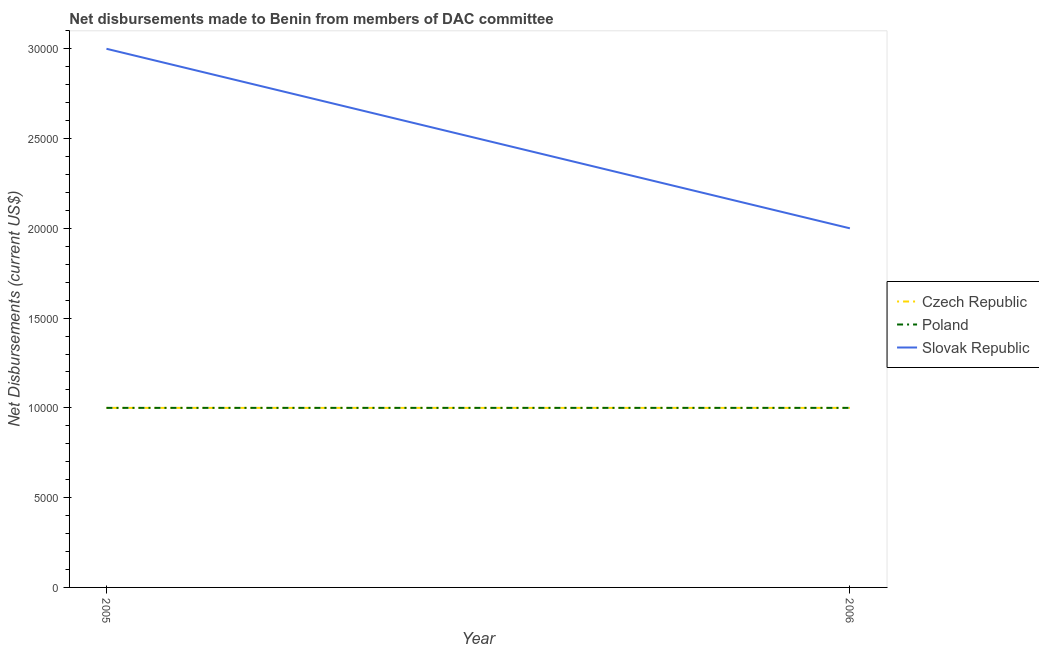How many different coloured lines are there?
Give a very brief answer. 3. What is the net disbursements made by slovak republic in 2006?
Give a very brief answer. 2.00e+04. Across all years, what is the maximum net disbursements made by czech republic?
Provide a short and direct response. 10000. Across all years, what is the minimum net disbursements made by slovak republic?
Offer a terse response. 2.00e+04. In which year was the net disbursements made by slovak republic maximum?
Provide a short and direct response. 2005. In which year was the net disbursements made by czech republic minimum?
Make the answer very short. 2005. What is the total net disbursements made by poland in the graph?
Ensure brevity in your answer.  2.00e+04. What is the difference between the net disbursements made by slovak republic in 2006 and the net disbursements made by poland in 2005?
Offer a terse response. 10000. In the year 2006, what is the difference between the net disbursements made by slovak republic and net disbursements made by poland?
Your response must be concise. 10000. In how many years, is the net disbursements made by poland greater than 5000 US$?
Keep it short and to the point. 2. What is the ratio of the net disbursements made by slovak republic in 2005 to that in 2006?
Offer a very short reply. 1.5. In how many years, is the net disbursements made by poland greater than the average net disbursements made by poland taken over all years?
Offer a very short reply. 0. How many lines are there?
Provide a succinct answer. 3. How many years are there in the graph?
Your answer should be compact. 2. What is the difference between two consecutive major ticks on the Y-axis?
Provide a short and direct response. 5000. Does the graph contain grids?
Give a very brief answer. No. How many legend labels are there?
Your response must be concise. 3. What is the title of the graph?
Make the answer very short. Net disbursements made to Benin from members of DAC committee. Does "Taxes on goods and services" appear as one of the legend labels in the graph?
Your answer should be compact. No. What is the label or title of the X-axis?
Ensure brevity in your answer.  Year. What is the label or title of the Y-axis?
Offer a very short reply. Net Disbursements (current US$). What is the Net Disbursements (current US$) in Czech Republic in 2005?
Provide a short and direct response. 10000. What is the Net Disbursements (current US$) in Poland in 2005?
Offer a terse response. 10000. What is the Net Disbursements (current US$) in Slovak Republic in 2005?
Give a very brief answer. 3.00e+04. What is the Net Disbursements (current US$) of Czech Republic in 2006?
Provide a succinct answer. 10000. What is the Net Disbursements (current US$) in Poland in 2006?
Provide a short and direct response. 10000. What is the Net Disbursements (current US$) in Slovak Republic in 2006?
Keep it short and to the point. 2.00e+04. Across all years, what is the maximum Net Disbursements (current US$) of Czech Republic?
Offer a terse response. 10000. Across all years, what is the maximum Net Disbursements (current US$) in Poland?
Your response must be concise. 10000. Across all years, what is the maximum Net Disbursements (current US$) of Slovak Republic?
Your response must be concise. 3.00e+04. Across all years, what is the minimum Net Disbursements (current US$) in Czech Republic?
Provide a succinct answer. 10000. Across all years, what is the minimum Net Disbursements (current US$) of Poland?
Offer a very short reply. 10000. What is the total Net Disbursements (current US$) in Czech Republic in the graph?
Your response must be concise. 2.00e+04. What is the difference between the Net Disbursements (current US$) of Czech Republic in 2005 and the Net Disbursements (current US$) of Slovak Republic in 2006?
Your response must be concise. -10000. What is the difference between the Net Disbursements (current US$) in Poland in 2005 and the Net Disbursements (current US$) in Slovak Republic in 2006?
Your answer should be very brief. -10000. What is the average Net Disbursements (current US$) of Poland per year?
Provide a succinct answer. 10000. What is the average Net Disbursements (current US$) of Slovak Republic per year?
Make the answer very short. 2.50e+04. In the year 2005, what is the difference between the Net Disbursements (current US$) in Czech Republic and Net Disbursements (current US$) in Poland?
Provide a succinct answer. 0. In the year 2005, what is the difference between the Net Disbursements (current US$) of Poland and Net Disbursements (current US$) of Slovak Republic?
Your answer should be compact. -2.00e+04. In the year 2006, what is the difference between the Net Disbursements (current US$) in Czech Republic and Net Disbursements (current US$) in Poland?
Provide a short and direct response. 0. In the year 2006, what is the difference between the Net Disbursements (current US$) in Czech Republic and Net Disbursements (current US$) in Slovak Republic?
Offer a terse response. -10000. In the year 2006, what is the difference between the Net Disbursements (current US$) in Poland and Net Disbursements (current US$) in Slovak Republic?
Give a very brief answer. -10000. What is the difference between the highest and the lowest Net Disbursements (current US$) of Poland?
Make the answer very short. 0. 